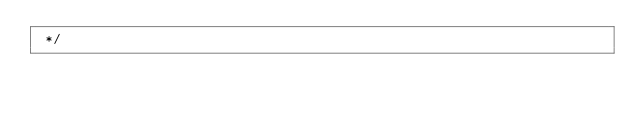<code> <loc_0><loc_0><loc_500><loc_500><_JavaScript_> */</code> 